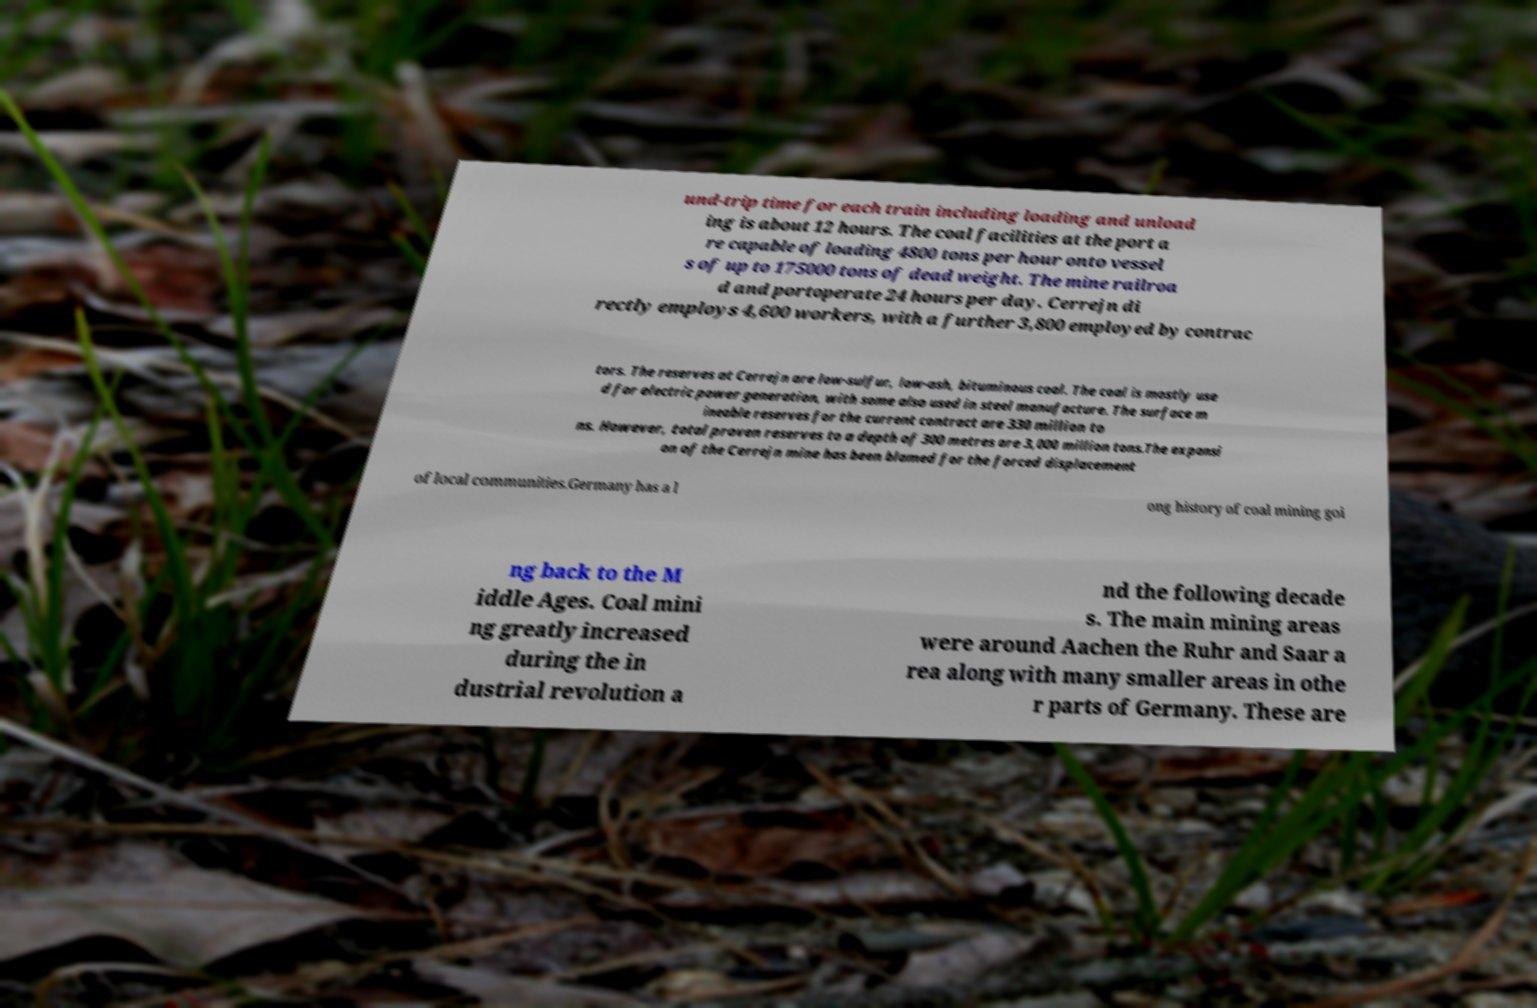I need the written content from this picture converted into text. Can you do that? und-trip time for each train including loading and unload ing is about 12 hours. The coal facilities at the port a re capable of loading 4800 tons per hour onto vessel s of up to 175000 tons of dead weight. The mine railroa d and portoperate 24 hours per day. Cerrejn di rectly employs 4,600 workers, with a further 3,800 employed by contrac tors. The reserves at Cerrejn are low-sulfur, low-ash, bituminous coal. The coal is mostly use d for electric power generation, with some also used in steel manufacture. The surface m ineable reserves for the current contract are 330 million to ns. However, total proven reserves to a depth of 300 metres are 3,000 million tons.The expansi on of the Cerrejn mine has been blamed for the forced displacement of local communities.Germany has a l ong history of coal mining goi ng back to the M iddle Ages. Coal mini ng greatly increased during the in dustrial revolution a nd the following decade s. The main mining areas were around Aachen the Ruhr and Saar a rea along with many smaller areas in othe r parts of Germany. These are 